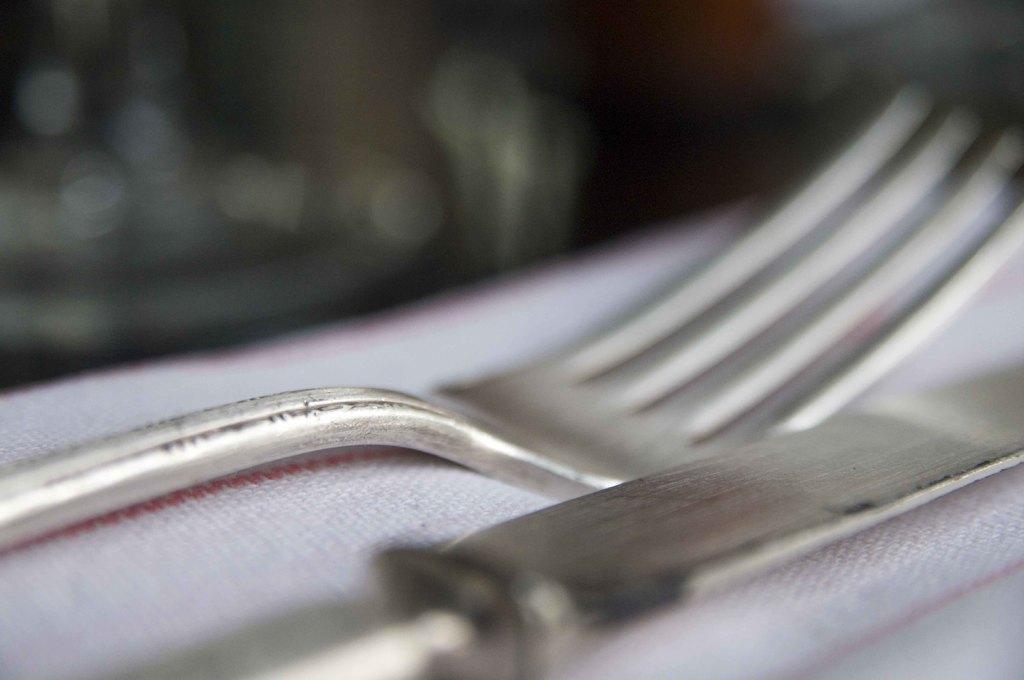Describe this image in one or two sentences. There is a knife and a fork in the foreground and the background is blurry. 